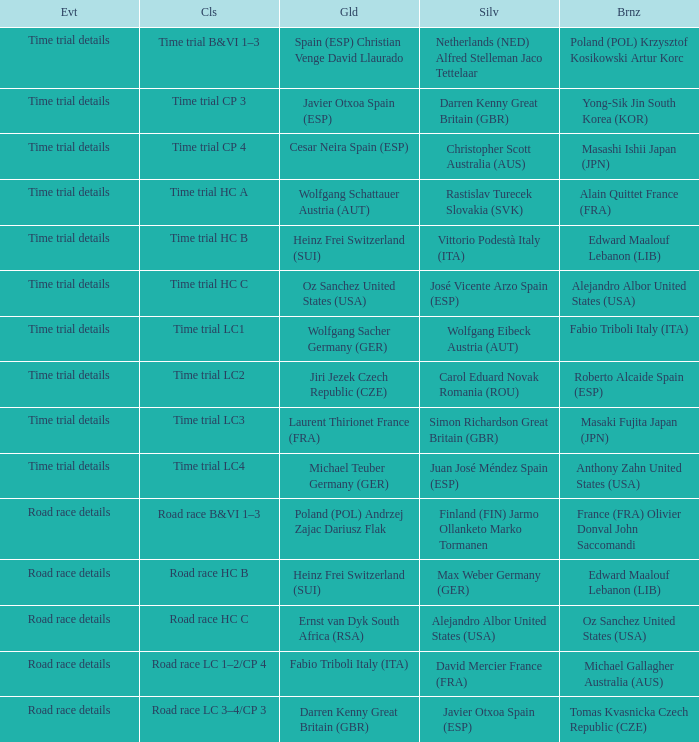Who received gold when silver is wolfgang eibeck austria (aut)? Wolfgang Sacher Germany (GER). 